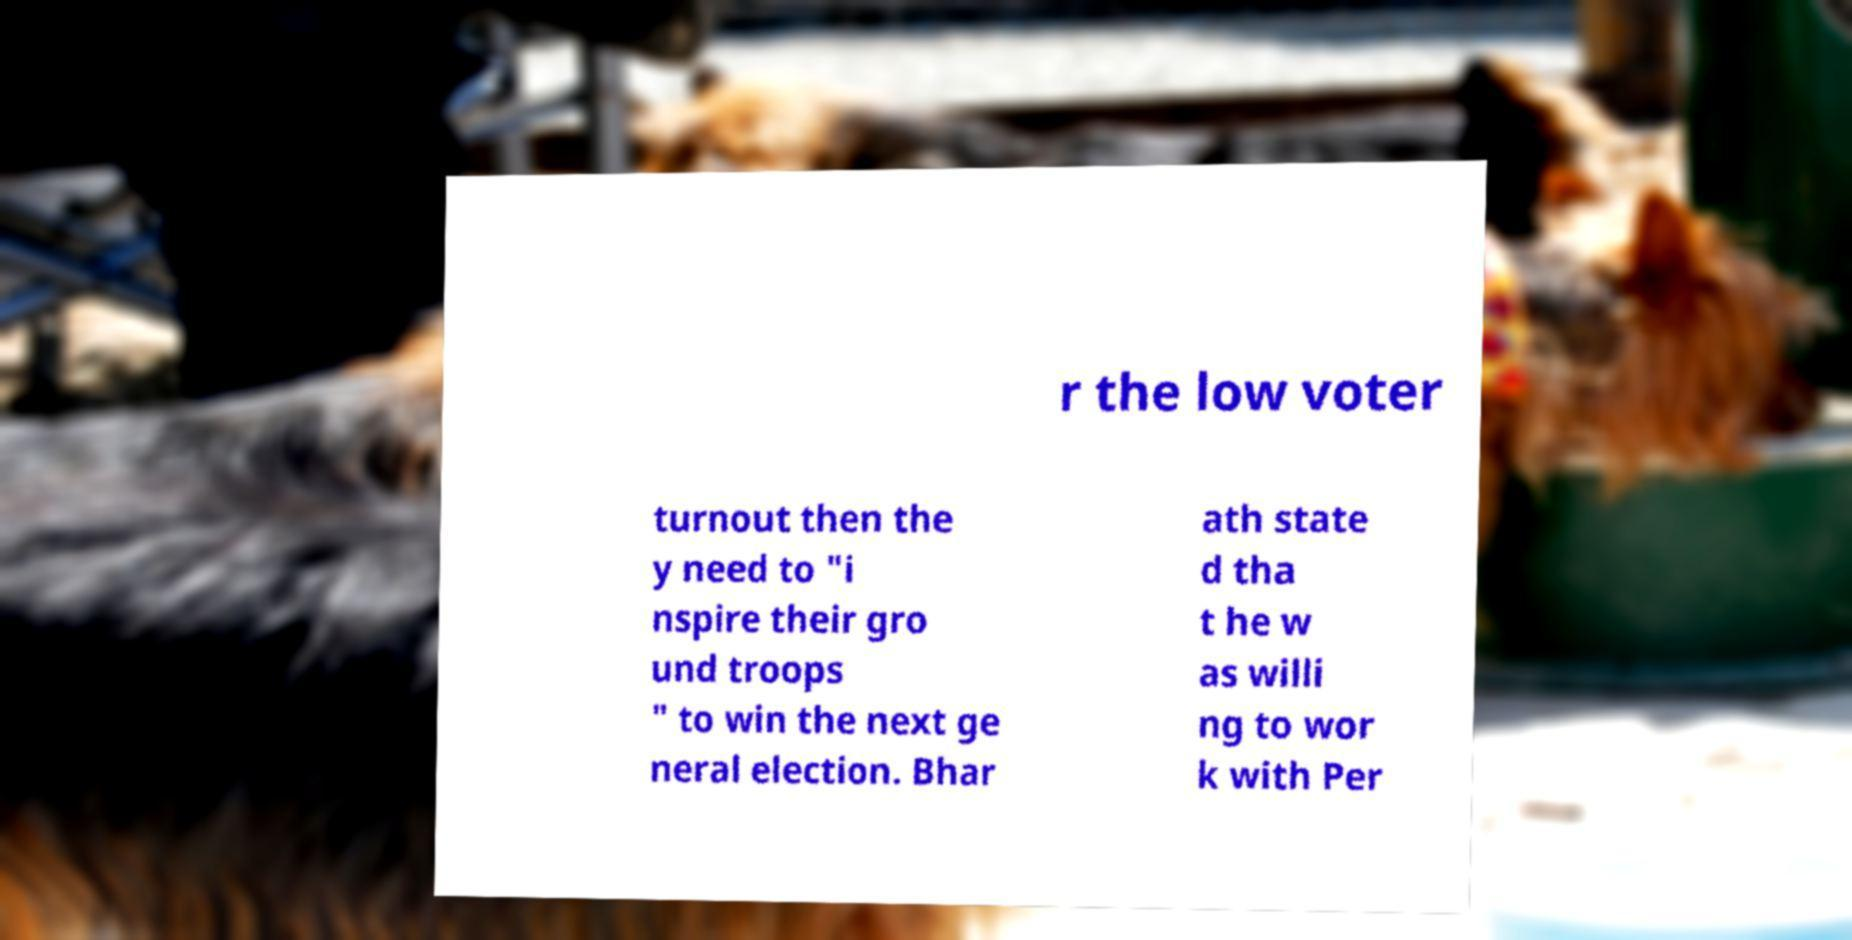Can you read and provide the text displayed in the image?This photo seems to have some interesting text. Can you extract and type it out for me? r the low voter turnout then the y need to "i nspire their gro und troops " to win the next ge neral election. Bhar ath state d tha t he w as willi ng to wor k with Per 